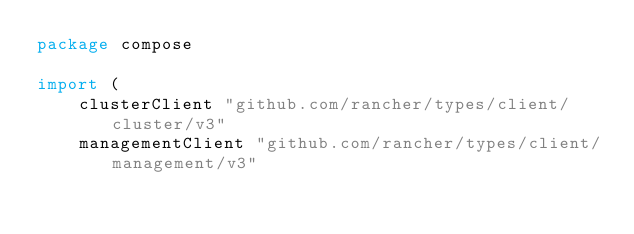<code> <loc_0><loc_0><loc_500><loc_500><_Go_>package compose

import (
	clusterClient "github.com/rancher/types/client/cluster/v3"
	managementClient "github.com/rancher/types/client/management/v3"</code> 